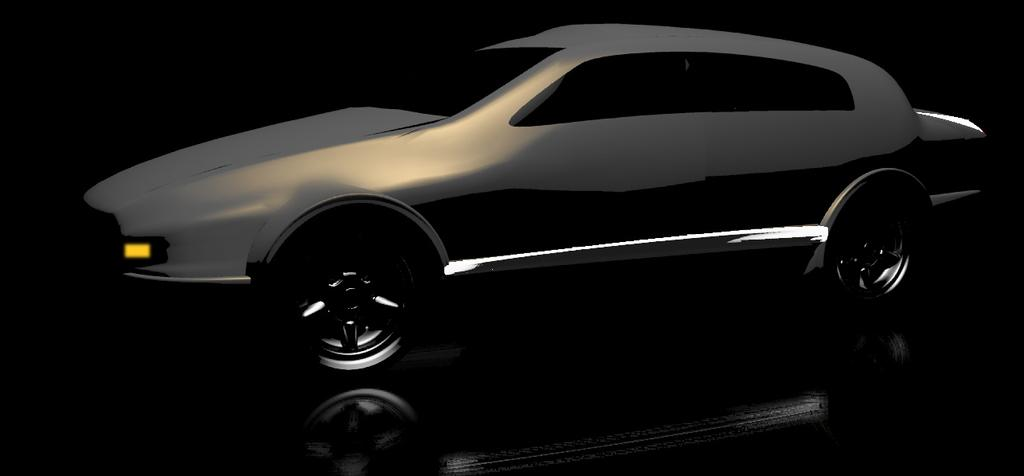What color is the car in the image? The car in the image is grey. What is the color of the background in the image? The background in the image is black. How many pies are on the car in the image? There are no pies present in the image; it only features a grey car against a black background. 